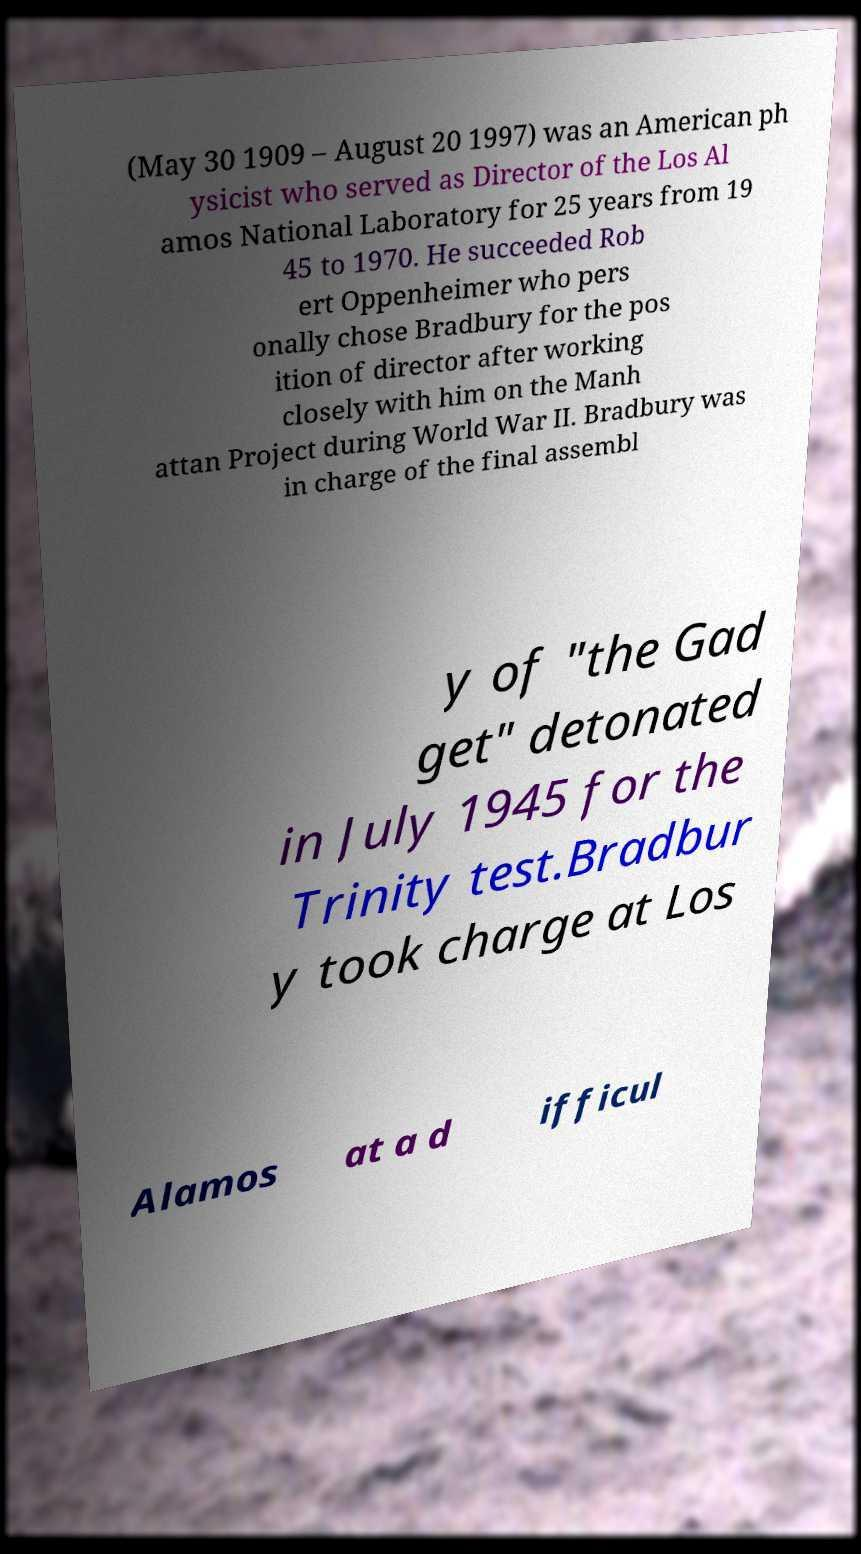Please read and relay the text visible in this image. What does it say? (May 30 1909 – August 20 1997) was an American ph ysicist who served as Director of the Los Al amos National Laboratory for 25 years from 19 45 to 1970. He succeeded Rob ert Oppenheimer who pers onally chose Bradbury for the pos ition of director after working closely with him on the Manh attan Project during World War II. Bradbury was in charge of the final assembl y of "the Gad get" detonated in July 1945 for the Trinity test.Bradbur y took charge at Los Alamos at a d ifficul 